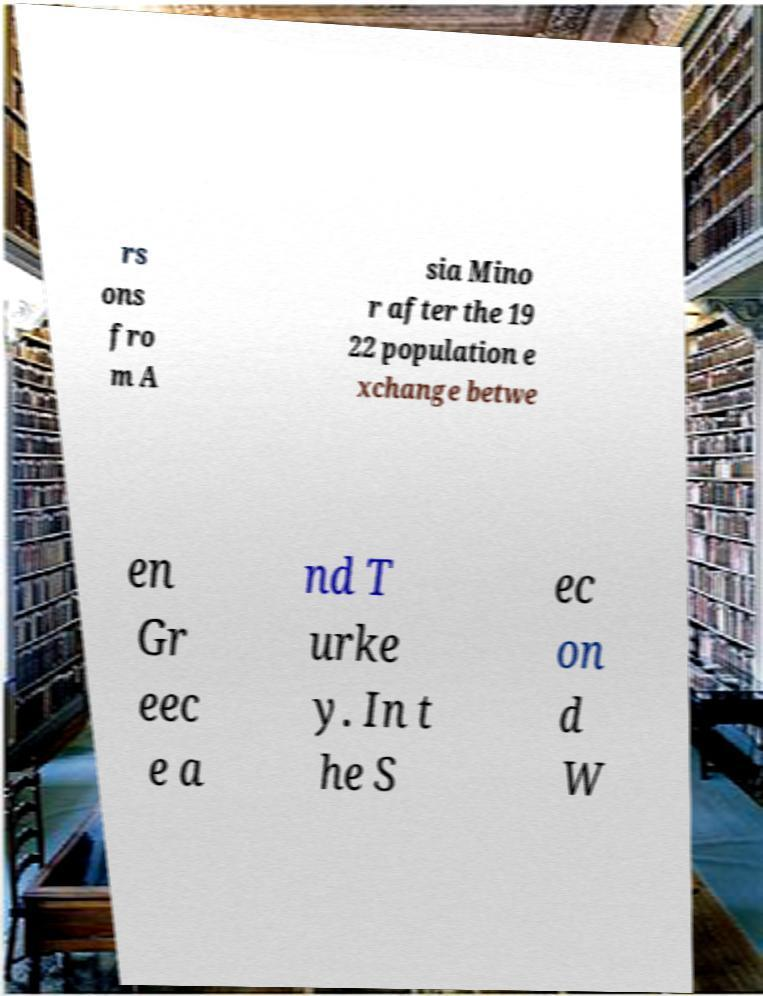Please read and relay the text visible in this image. What does it say? rs ons fro m A sia Mino r after the 19 22 population e xchange betwe en Gr eec e a nd T urke y. In t he S ec on d W 